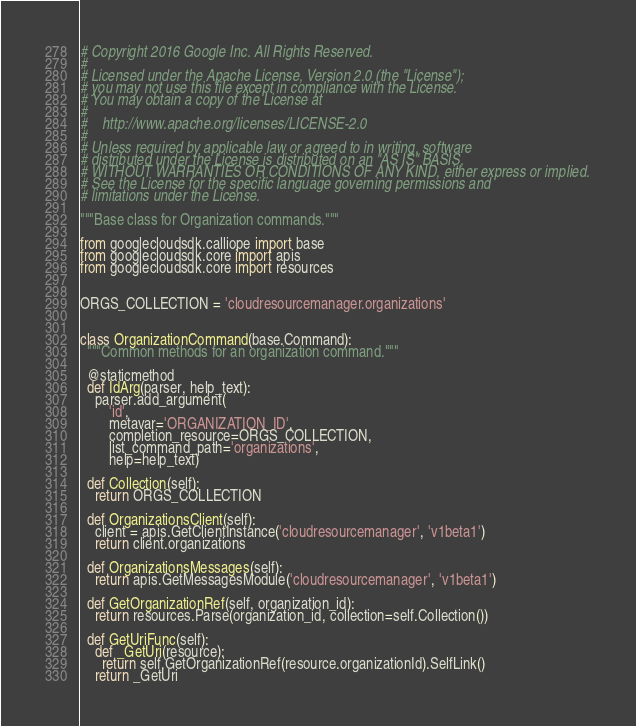Convert code to text. <code><loc_0><loc_0><loc_500><loc_500><_Python_># Copyright 2016 Google Inc. All Rights Reserved.
#
# Licensed under the Apache License, Version 2.0 (the "License");
# you may not use this file except in compliance with the License.
# You may obtain a copy of the License at
#
#    http://www.apache.org/licenses/LICENSE-2.0
#
# Unless required by applicable law or agreed to in writing, software
# distributed under the License is distributed on an "AS IS" BASIS,
# WITHOUT WARRANTIES OR CONDITIONS OF ANY KIND, either express or implied.
# See the License for the specific language governing permissions and
# limitations under the License.

"""Base class for Organization commands."""

from googlecloudsdk.calliope import base
from googlecloudsdk.core import apis
from googlecloudsdk.core import resources


ORGS_COLLECTION = 'cloudresourcemanager.organizations'


class OrganizationCommand(base.Command):
  """Common methods for an organization command."""

  @staticmethod
  def IdArg(parser, help_text):
    parser.add_argument(
        'id',
        metavar='ORGANIZATION_ID',
        completion_resource=ORGS_COLLECTION,
        list_command_path='organizations',
        help=help_text)

  def Collection(self):
    return ORGS_COLLECTION

  def OrganizationsClient(self):
    client = apis.GetClientInstance('cloudresourcemanager', 'v1beta1')
    return client.organizations

  def OrganizationsMessages(self):
    return apis.GetMessagesModule('cloudresourcemanager', 'v1beta1')

  def GetOrganizationRef(self, organization_id):
    return resources.Parse(organization_id, collection=self.Collection())

  def GetUriFunc(self):
    def _GetUri(resource):
      return self.GetOrganizationRef(resource.organizationId).SelfLink()
    return _GetUri
</code> 